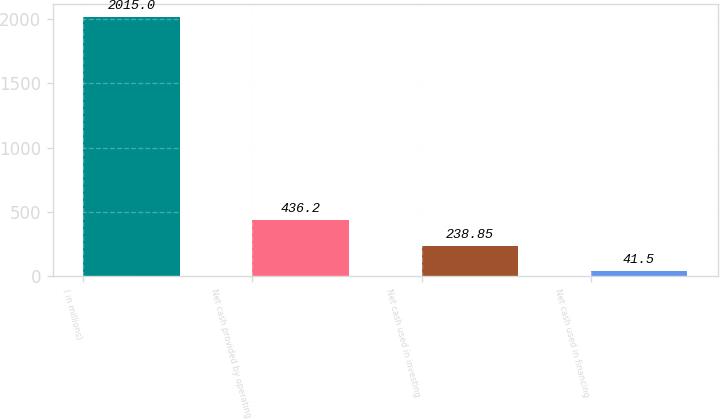<chart> <loc_0><loc_0><loc_500><loc_500><bar_chart><fcel>( in millions)<fcel>Net cash provided by operating<fcel>Net cash used in investing<fcel>Net cash used in financing<nl><fcel>2015<fcel>436.2<fcel>238.85<fcel>41.5<nl></chart> 